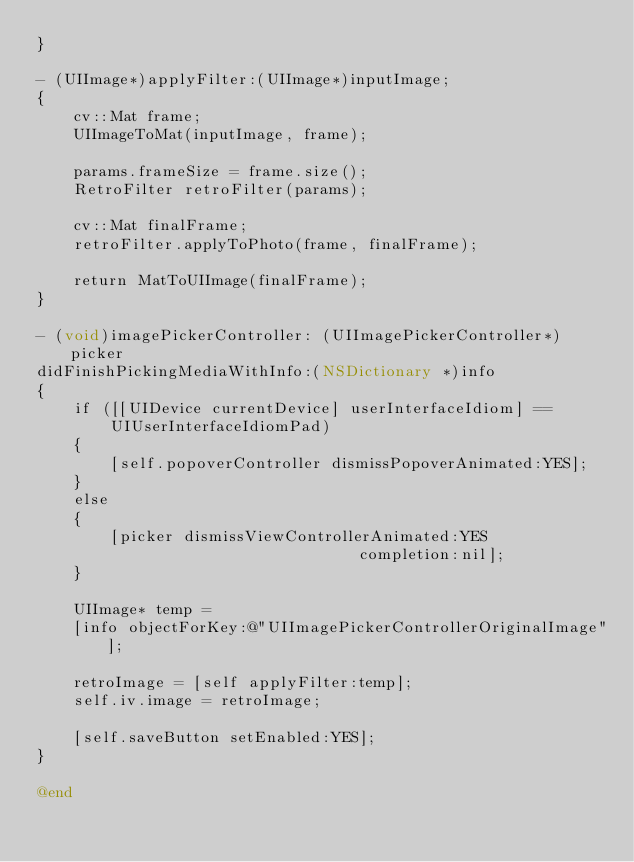<code> <loc_0><loc_0><loc_500><loc_500><_ObjectiveC_>}

- (UIImage*)applyFilter:(UIImage*)inputImage;
{
    cv::Mat frame;
    UIImageToMat(inputImage, frame);
    
    params.frameSize = frame.size();
    RetroFilter retroFilter(params);
    
    cv::Mat finalFrame;
    retroFilter.applyToPhoto(frame, finalFrame);
    
    return MatToUIImage(finalFrame);
}

- (void)imagePickerController: (UIImagePickerController*)picker
didFinishPickingMediaWithInfo:(NSDictionary *)info
{
    if ([[UIDevice currentDevice] userInterfaceIdiom] ==
        UIUserInterfaceIdiomPad)
    {
        [self.popoverController dismissPopoverAnimated:YES];
    }
    else
    {
        [picker dismissViewControllerAnimated:YES
                                   completion:nil];
    }
    
    UIImage* temp =
    [info objectForKey:@"UIImagePickerControllerOriginalImage"];
    
    retroImage = [self applyFilter:temp];
    self.iv.image = retroImage;
    
    [self.saveButton setEnabled:YES];
}

@end

</code> 